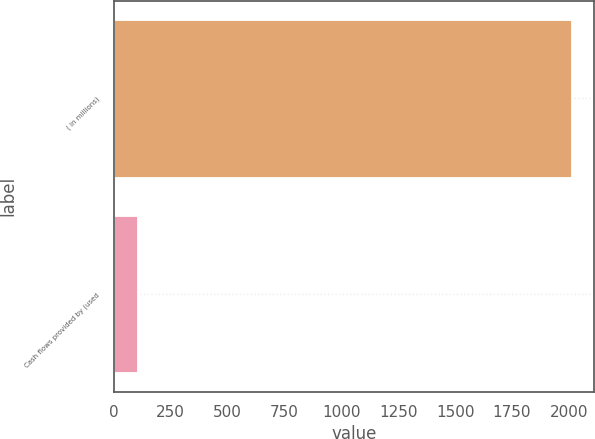Convert chart. <chart><loc_0><loc_0><loc_500><loc_500><bar_chart><fcel>( in millions)<fcel>Cash flows provided by (used<nl><fcel>2009<fcel>100.8<nl></chart> 